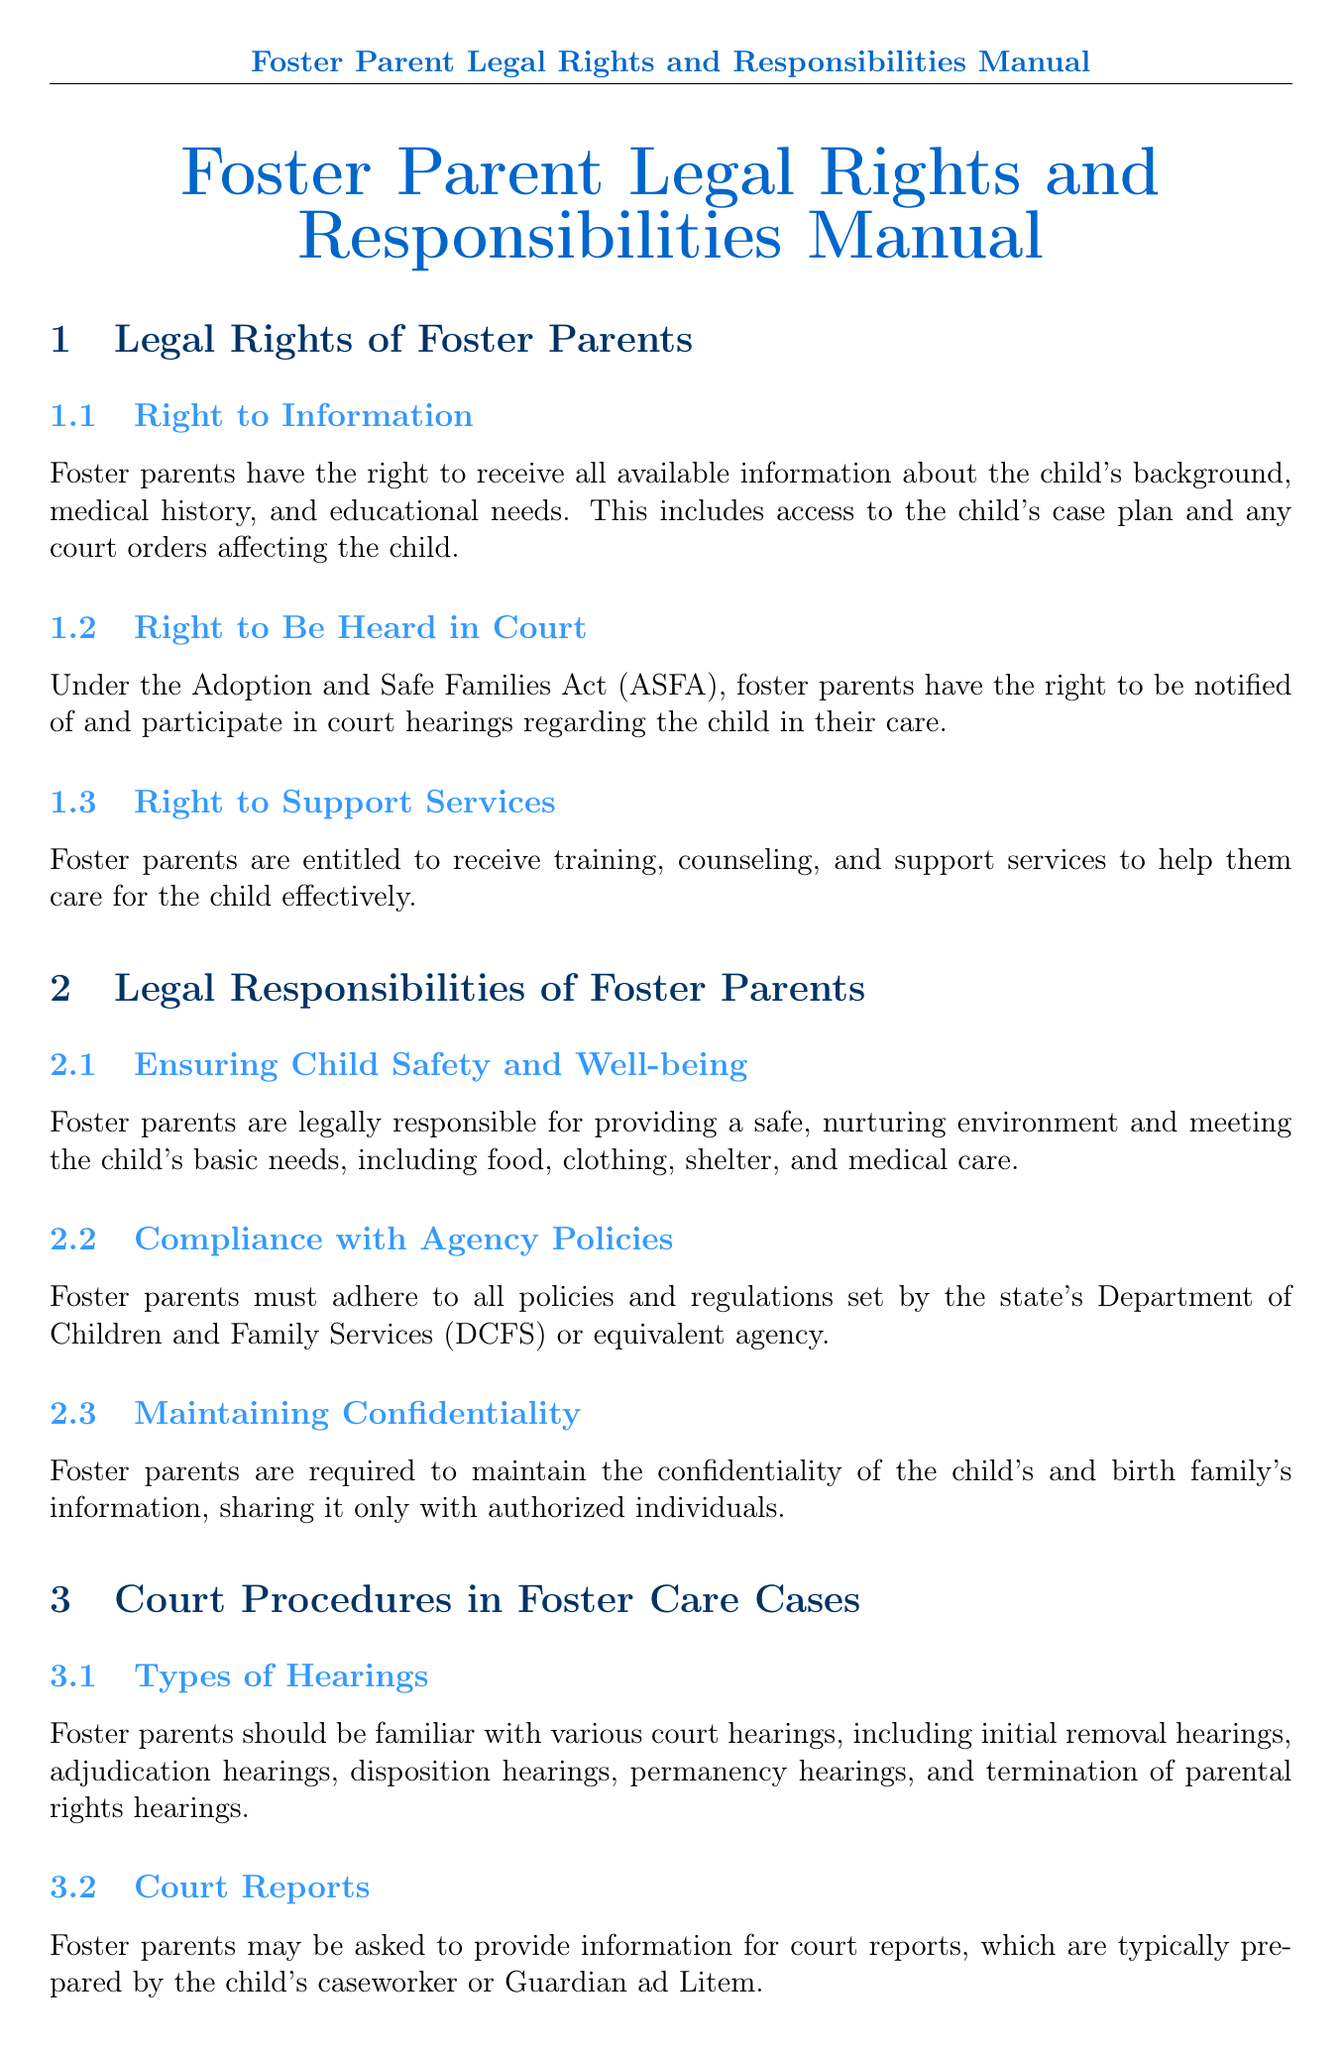What is the right of foster parents regarding information? Foster parents have the right to receive all available information about the child's background, medical history, and educational needs.
Answer: Right to Information What act gives foster parents the right to be heard in court? The Adoption and Safe Families Act (ASFA) provides this right to foster parents.
Answer: Adoption and Safe Families Act (ASFA) What is one of the legal responsibilities of foster parents? Foster parents are legally responsible for providing a safe, nurturing environment and meeting the child's basic needs.
Answer: Ensuring Child Safety and Well-being How many types of hearings should foster parents be familiar with? Foster parents should be familiar with various court hearings, though the exact number is not specified.
Answer: Various What should foster parents do to advocate for the child? Foster parents should keep detailed records of the child's behaviors, medical appointments, and school progress.
Answer: Documenting Concerns What is one advocacy technique for foster parents? Collaborate with the child's team, including the caseworker and therapists.
Answer: Collaborating with the Child's Team What is essential for foster parents to maintain regarding the child's information? Foster parents are required to maintain the confidentiality of the child's and birth family's information.
Answer: Confidentiality What organizations can foster parents join for support? Foster parents can join organizations like the National Foster Parent Association (NFPA).
Answer: National Foster Parent Association (NFPA) What training resource is mentioned for foster parents? The Child Welfare Information Gateway offers training opportunities for foster parents.
Answer: Child Welfare Information Gateway 